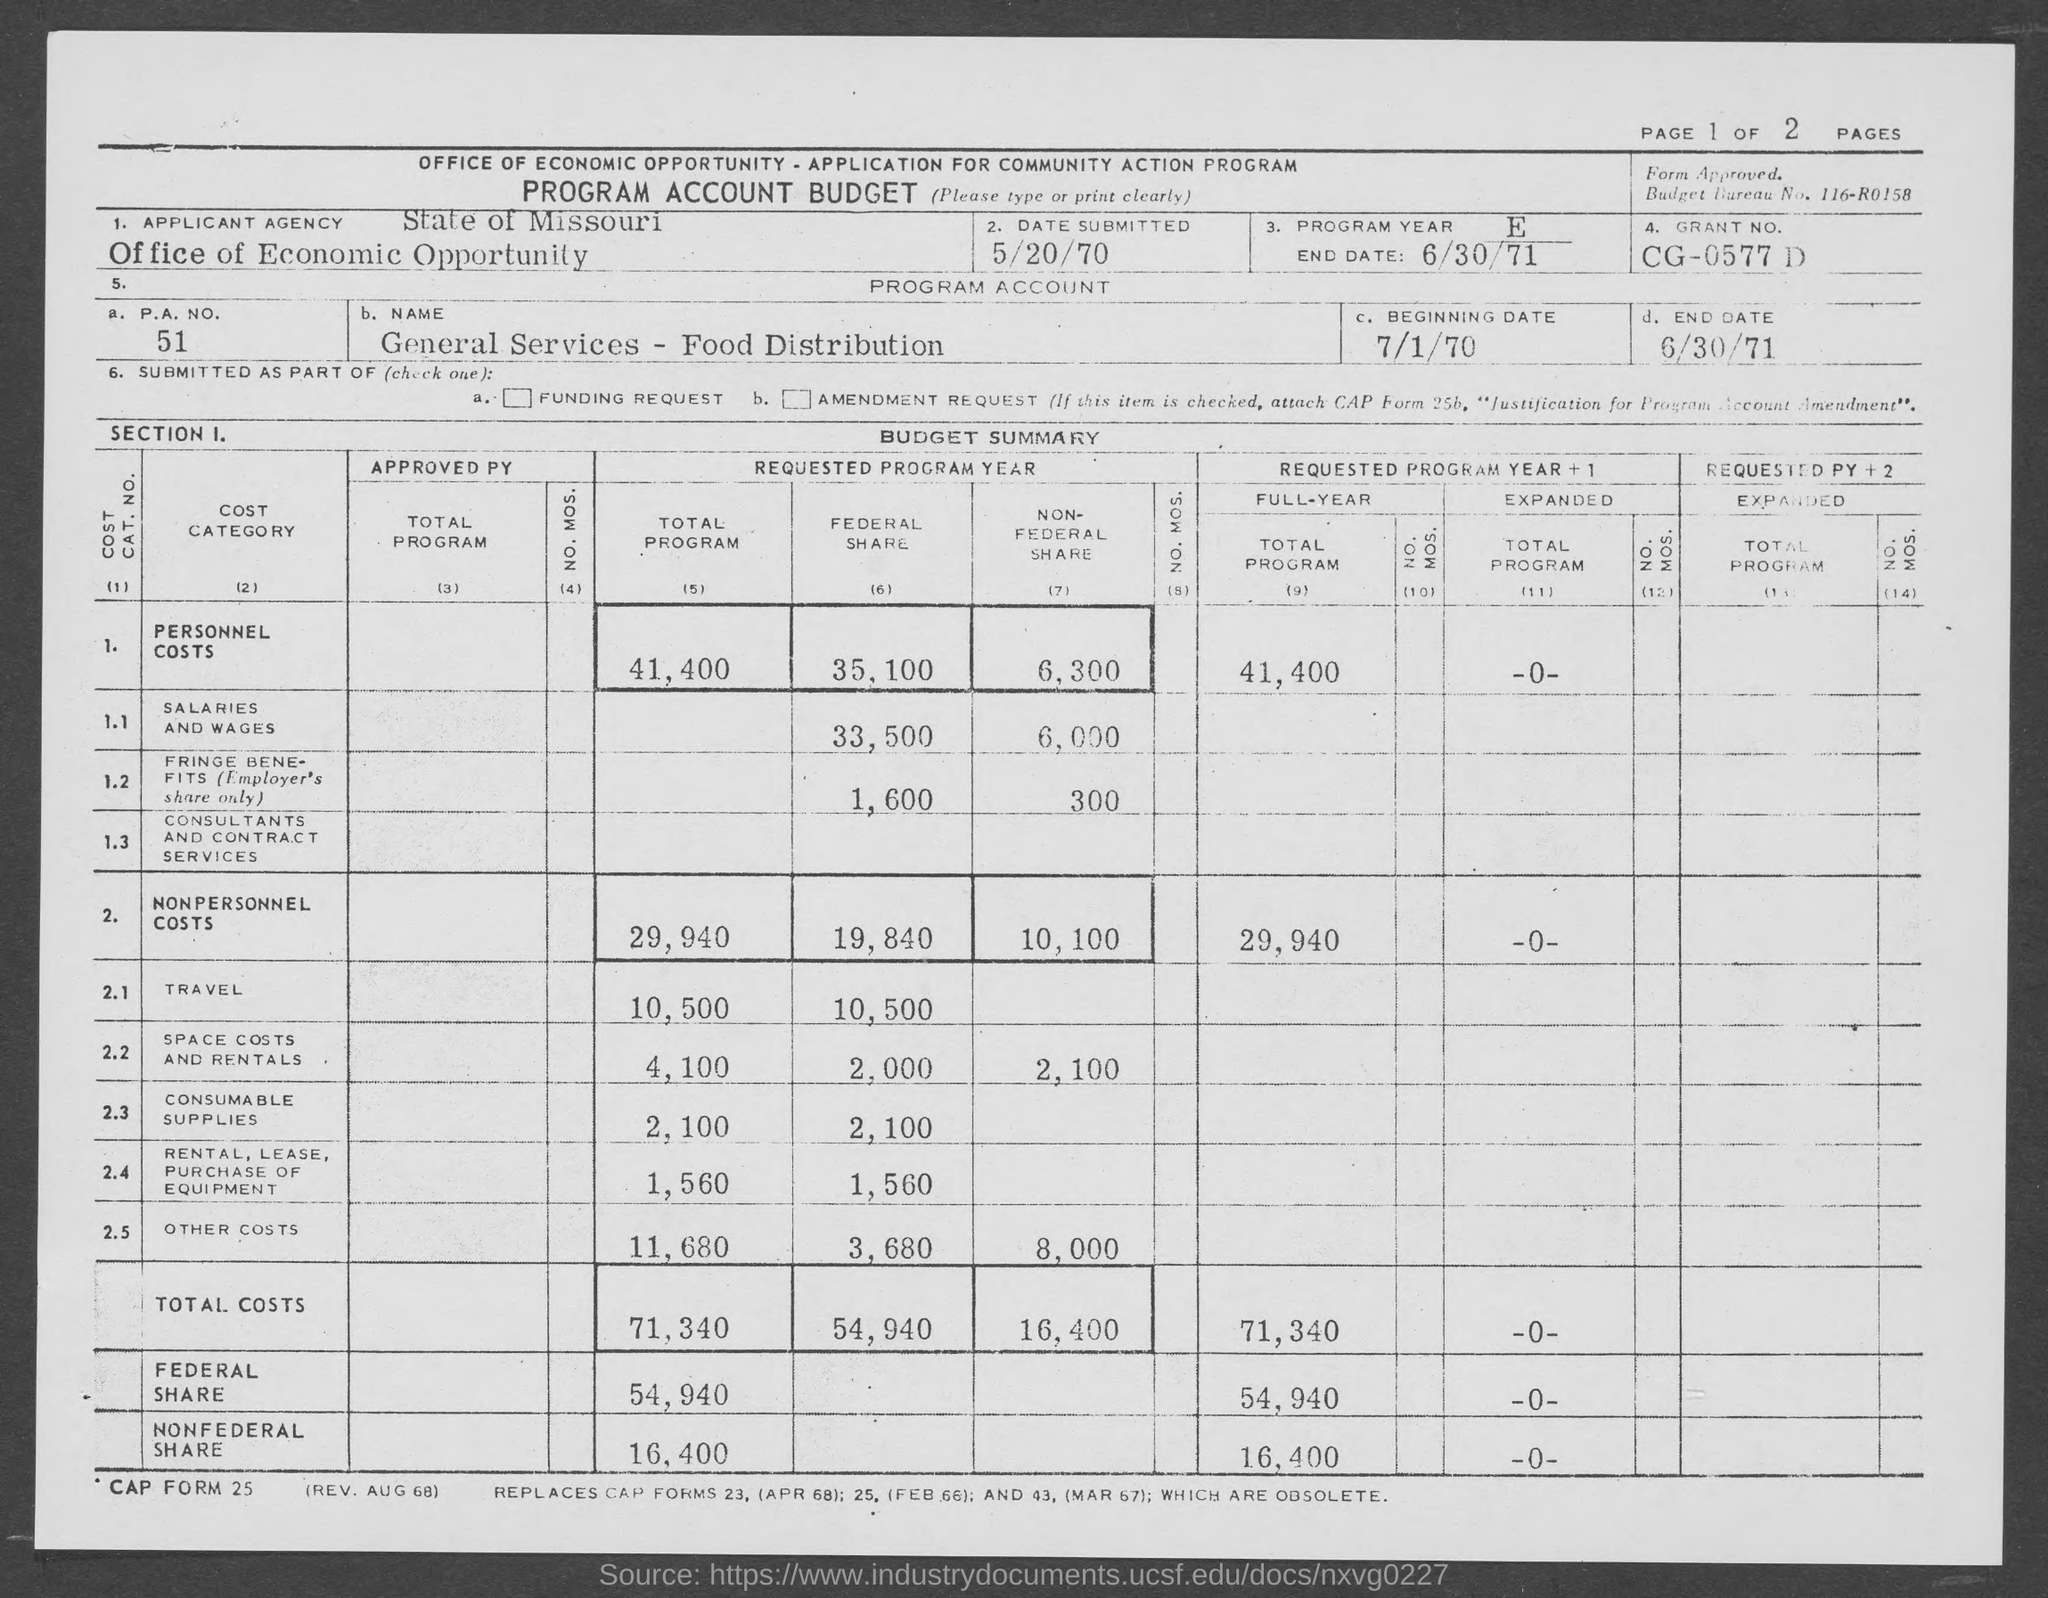When is the Date submitted?
Provide a short and direct response. 5/20/70. When is the program end date?
Provide a succinct answer. 6/30/71. When is the beginning date?
Your answer should be compact. 7/1/70. What is P.A.No.?
Provide a succinct answer. 51. What is the Grant No.?
Your response must be concise. CG-0577 D. 